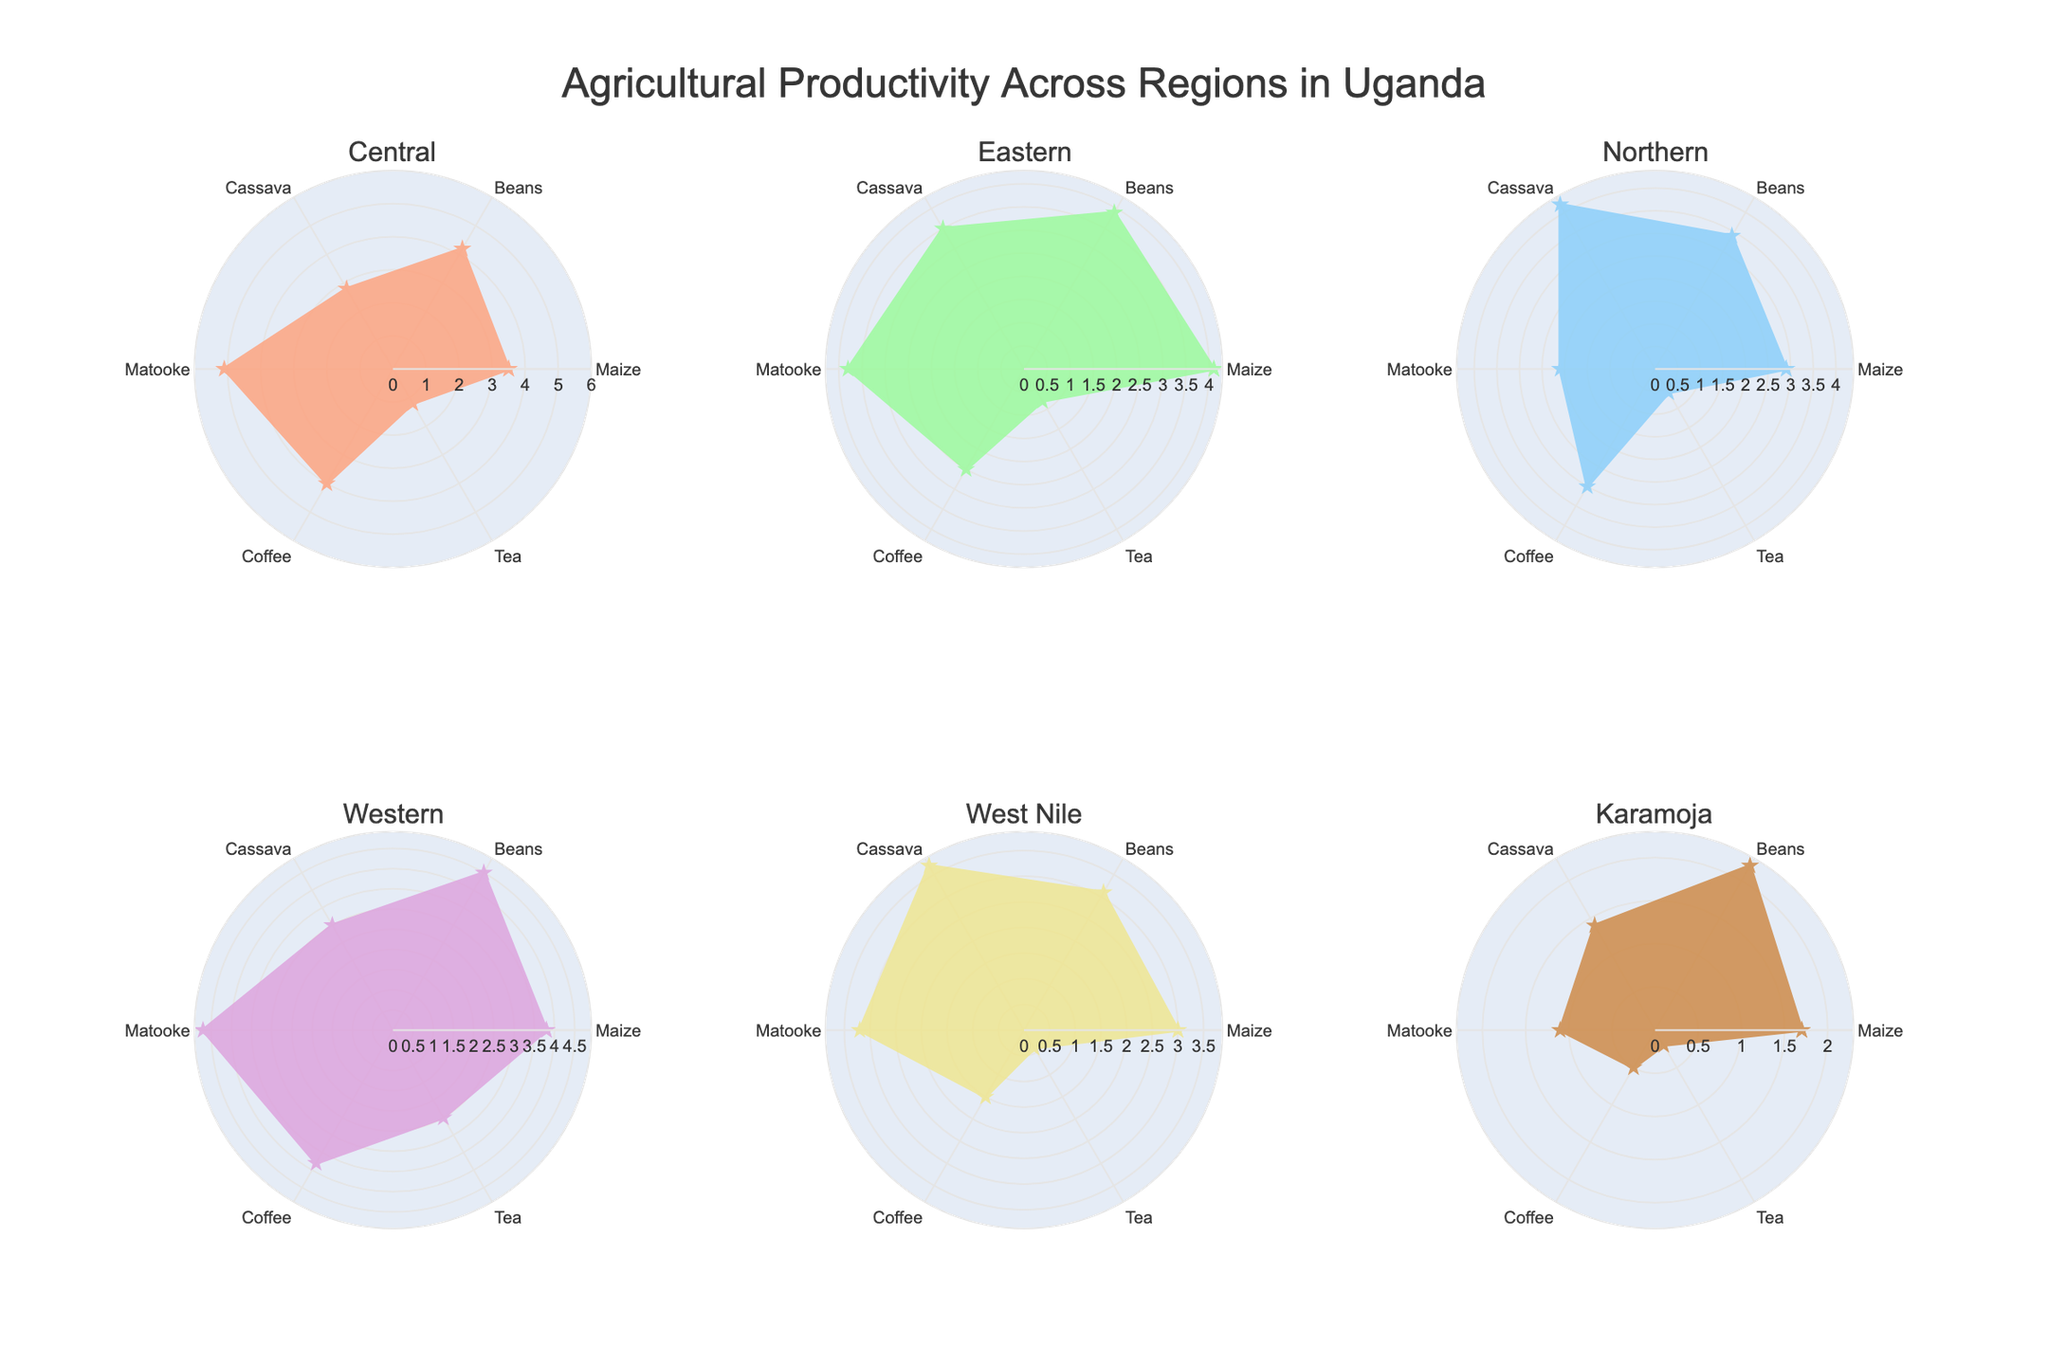Which region has the highest productivity for Matooke? By examining each subplot, the Western region's radar chart extends the furthest for Matooke compared to other regions.
Answer: Western Which region shows the lowest productivity for Tea? By reviewing the visual data for Tea in all subplots, Karamoja's radar chart has the smallest extension for Tea.
Answer: Karamoja What is the average productivity of Maize across all regions? Summing the productivity values of Maize across all regions (3.5 + 4.1 + 2.9 + 3.8 + 3.0 + 1.7), we get 19. Multiply this by the number of regions (6), the average Maize productivity is 19/6 = 3.17
Answer: 3.17 Compare the productivity of Beans between the Central and Western regions. Which one is higher? The extension of the radar chart for Beans is higher in the Western region at 4.5 compared to the Central region at 4.2.
Answer: Western Which product shows the highest productivity in Karamoja? In Karamoja's radar chart, Maize has the highest value, extending the furthest at 1.7.
Answer: Maize How does Cassava productivity in Northern Uganda compare to Eastern Uganda? The radar chart for Northern Uganda extends to 4.2 for Cassava, whereas Eastern Uganda extends to 3.5. Thus, Northern Uganda has higher productivity for Cassava.
Answer: Northern Uganda Calculate the difference in productivity for Coffee between the Eastern and West Nile regions. Coffee productivity in the Eastern region is 2.5, and in the West Nile region, it is 1.5. The difference is 2.5 - 1.5 = 1.0.
Answer: 1.0 Which regions have a productivity value above 4.0 for any product? Reviewing the radar charts, the Central region (Matooke), Eastern region (Maize), Western region for multiple products (Beans, Matooke), and Northern region (Cassava) have values above 4.0 for one or more products.
Answer: Central, Eastern, Western, Northern Is there any product that all regions produce? Yes, reviewing each radar chart, all regions have values for Maize, Beans, Cassava, Matooke, Coffee, and Tea, this means all regions produce all the products listed.
Answer: Yes Compare Matooke productivity between the Central and Northern regions by how much does the Central region outperform the Northern region? Matooke productivity in the Central region is 5.1, whereas, in the Northern region, it is 2.1. The difference is 5.1 - 2.1 = 3.0.
Answer: 3.0 